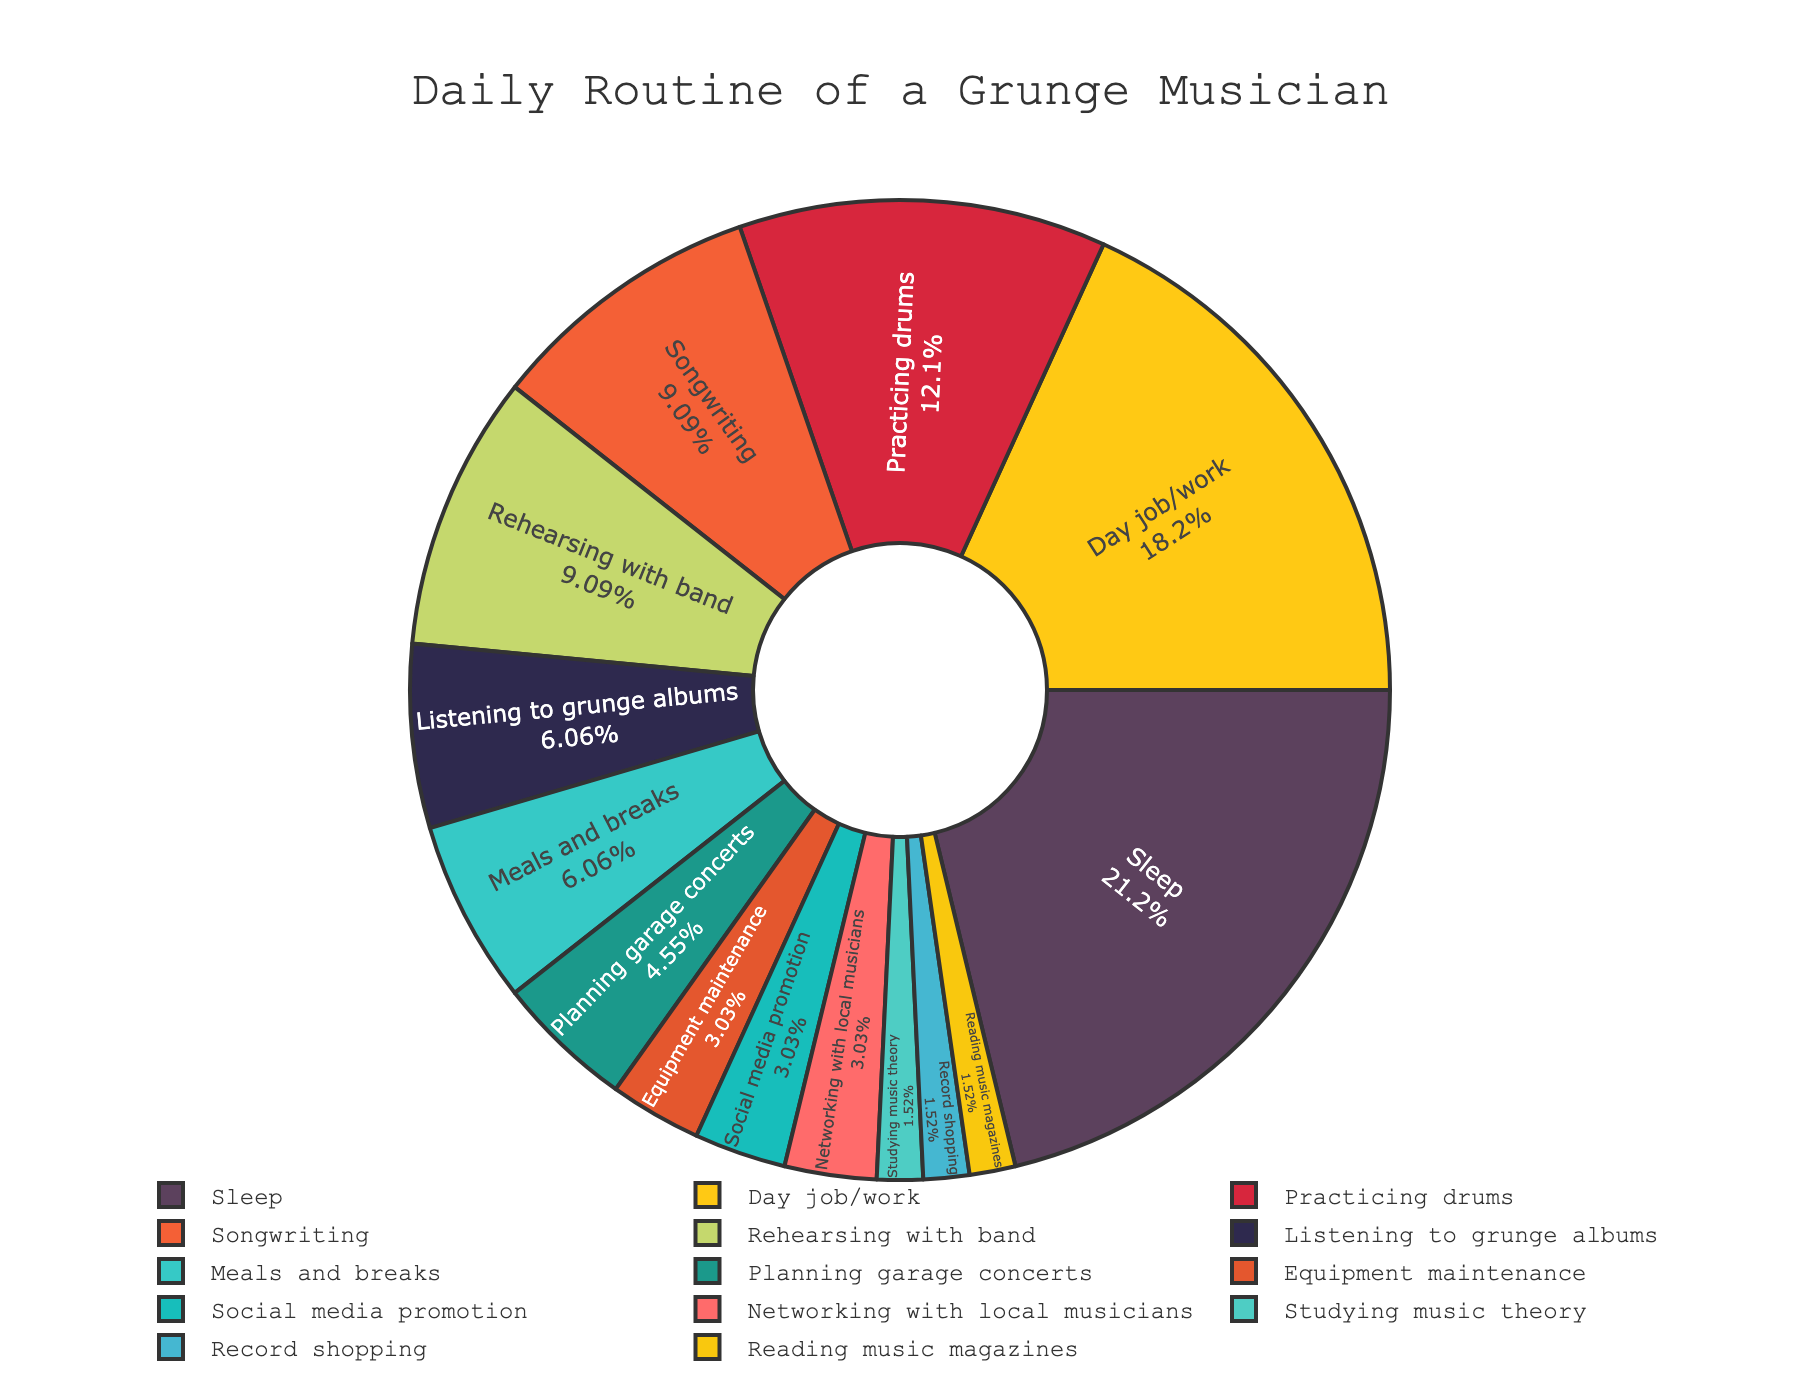Which activity takes up the most time in a grunge musician's daily routine? Observe the pie chart and identify the activity with the largest slice. In this case, it's "Day job/work."
Answer: Day job/work How many hours are spent on practicing drums and rehearsing with the band combined? Add the hours dedicated to "Practicing drums" (4 hours) and "Rehearsing with band" (3 hours), which totals 7 hours.
Answer: 7 hours What percentage of the day is spent on sleep? Look at the slice corresponding to "Sleep" and note the percentage indicated in the pie chart, which is 29.17%.
Answer: 29.17% Which activity takes less time: planning garage concerts or studying music theory? Compare the sizes of the pie slices for "Planning garage concerts" (1.5 hours) and "Studying music theory" (0.5 hour). "Studying music theory" takes less time.
Answer: Studying music theory Is more time spent on equipment maintenance or record shopping? Compare the slices for "Equipment maintenance" (1 hour) and "Record shopping" (0.5 hour). More time is spent on "Equipment maintenance."
Answer: Equipment maintenance What proportion of the grunge musician's day is dedicated to meals and breaks compared to songwriting? Meals and breaks take 2 hours, and songwriting takes 3 hours. Calculate the proportion: 2 hours / 3 hours = 2/3 ≈ 0.67.
Answer: 0.67 Which activity has a larger slice: social media promotion or networking with local musicians? Observe the pie chart and compare the slice sizes of "Social media promotion" (1 hour) and "Networking with local musicians" (1 hour). They are equal.
Answer: Equal How much time is spent on activities related to music compared to non-music activities? Add up the hours spent on all music-related activities (practicing drums, songwriting, listening to albums, planning concerts, rehearsing with the band, equipment maintenance, social media promotion, networking, studying theory, record shopping, and reading magazines) and compare with non-music activities (day job/work, sleep, meals, and breaks). 
Music-related: 4+3+2+1.5+3+1+1+1+0.5+0.5+0.5 = 18; Non-music: 6+7+2=15.
Answer: 18 to 15 Which activity uses a green slice in the pie chart? Observe the pie chart and identify which activity's slice is colored green. This color is assigned to "Listening to grunge albums."
Answer: Listening to grunge albums 